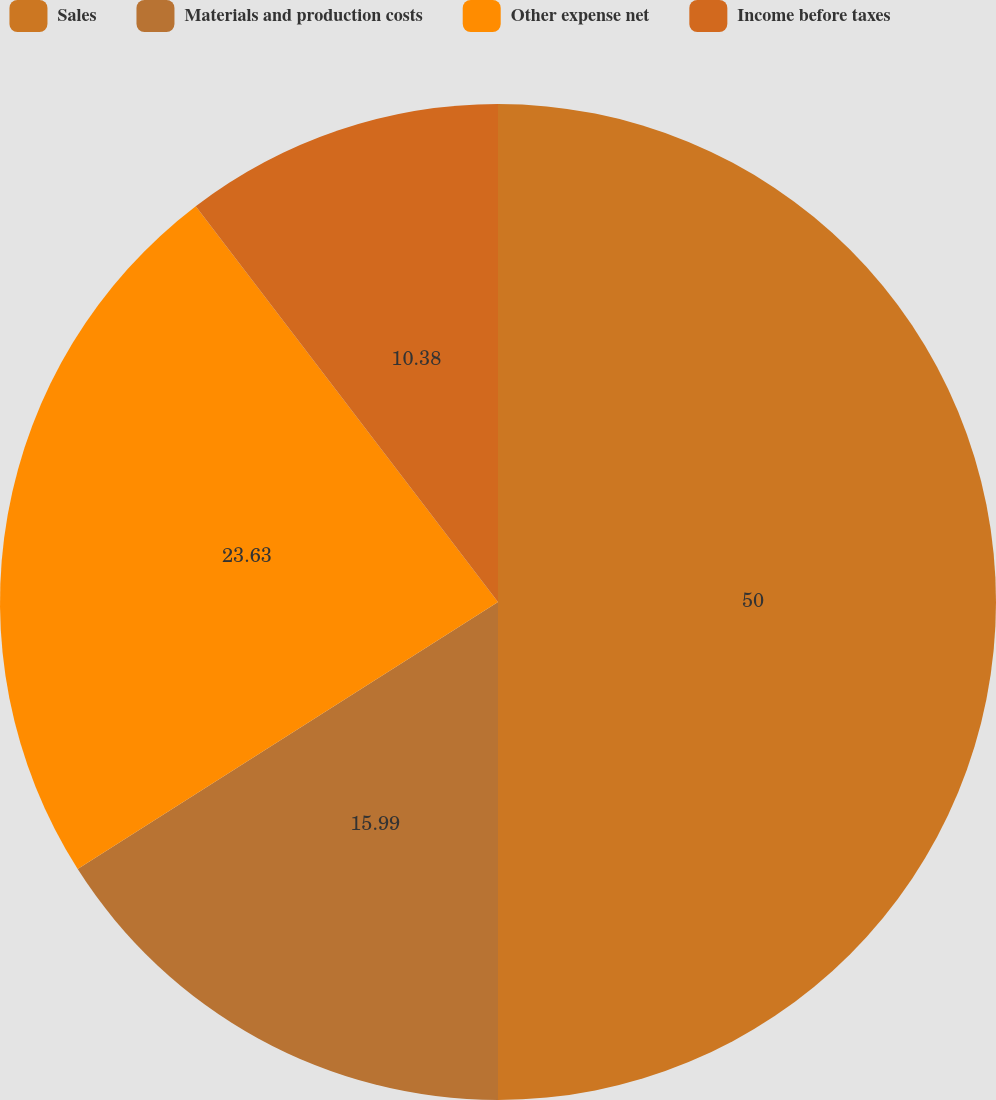Convert chart to OTSL. <chart><loc_0><loc_0><loc_500><loc_500><pie_chart><fcel>Sales<fcel>Materials and production costs<fcel>Other expense net<fcel>Income before taxes<nl><fcel>50.0%<fcel>15.99%<fcel>23.63%<fcel>10.38%<nl></chart> 